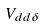Convert formula to latex. <formula><loc_0><loc_0><loc_500><loc_500>V _ { d d \delta }</formula> 